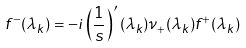<formula> <loc_0><loc_0><loc_500><loc_500>f ^ { - } ( \lambda _ { k } ) = - i \left ( \frac { 1 } { s } \right ) ^ { \prime } ( \lambda _ { k } ) { \nu _ { + } ( \lambda _ { k } ) } { f ^ { + } ( \lambda _ { k } ) }</formula> 